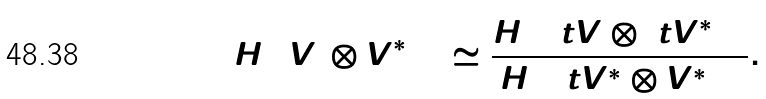Convert formula to latex. <formula><loc_0><loc_0><loc_500><loc_500>H ^ { 1 } ( V _ { 2 } \otimes V _ { 2 } ^ { * } ) _ { + } \simeq \frac { H ^ { 1 } ( \ t V \otimes \ t V ^ { * } ) _ { + } } { H ^ { 1 } ( \ t V ^ { * } \otimes V _ { 3 } ^ { * } ) _ { + } } .</formula> 